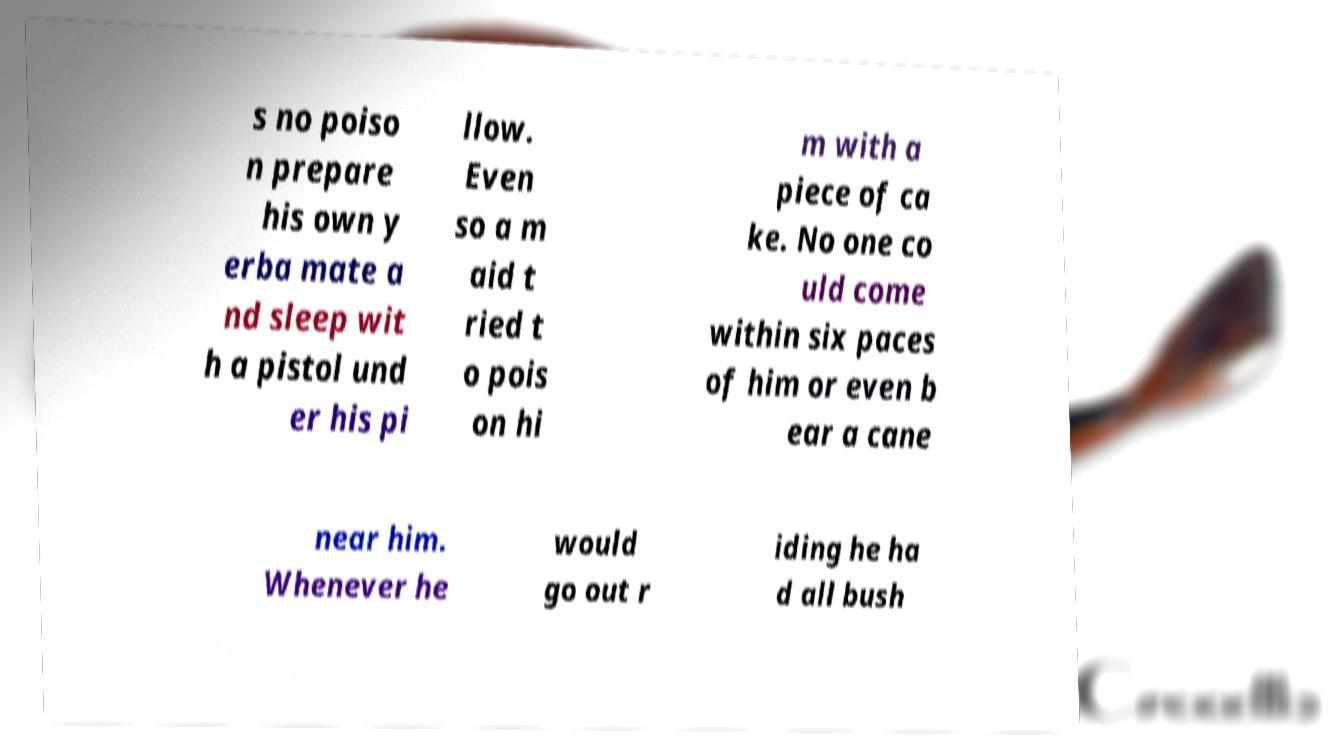Please identify and transcribe the text found in this image. s no poiso n prepare his own y erba mate a nd sleep wit h a pistol und er his pi llow. Even so a m aid t ried t o pois on hi m with a piece of ca ke. No one co uld come within six paces of him or even b ear a cane near him. Whenever he would go out r iding he ha d all bush 